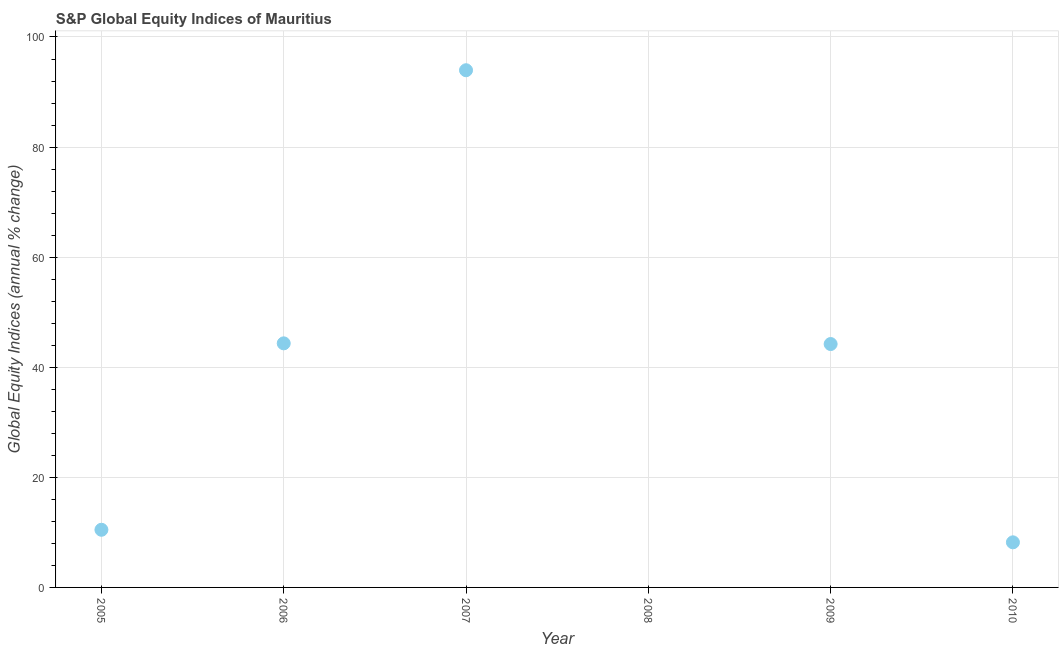What is the s&p global equity indices in 2007?
Offer a terse response. 93.96. Across all years, what is the maximum s&p global equity indices?
Your response must be concise. 93.96. In which year was the s&p global equity indices maximum?
Offer a terse response. 2007. What is the sum of the s&p global equity indices?
Your response must be concise. 201.19. What is the difference between the s&p global equity indices in 2005 and 2009?
Offer a very short reply. -33.74. What is the average s&p global equity indices per year?
Your answer should be compact. 33.53. What is the median s&p global equity indices?
Ensure brevity in your answer.  27.35. In how many years, is the s&p global equity indices greater than 16 %?
Your answer should be very brief. 3. What is the ratio of the s&p global equity indices in 2005 to that in 2009?
Offer a very short reply. 0.24. Is the s&p global equity indices in 2006 less than that in 2009?
Offer a terse response. No. What is the difference between the highest and the second highest s&p global equity indices?
Provide a succinct answer. 49.62. Is the sum of the s&p global equity indices in 2005 and 2006 greater than the maximum s&p global equity indices across all years?
Ensure brevity in your answer.  No. What is the difference between the highest and the lowest s&p global equity indices?
Keep it short and to the point. 93.96. Does the s&p global equity indices monotonically increase over the years?
Offer a very short reply. No. How many years are there in the graph?
Provide a succinct answer. 6. Does the graph contain grids?
Ensure brevity in your answer.  Yes. What is the title of the graph?
Your answer should be compact. S&P Global Equity Indices of Mauritius. What is the label or title of the X-axis?
Your answer should be compact. Year. What is the label or title of the Y-axis?
Your response must be concise. Global Equity Indices (annual % change). What is the Global Equity Indices (annual % change) in 2005?
Keep it short and to the point. 10.47. What is the Global Equity Indices (annual % change) in 2006?
Provide a succinct answer. 44.34. What is the Global Equity Indices (annual % change) in 2007?
Your answer should be very brief. 93.96. What is the Global Equity Indices (annual % change) in 2009?
Your response must be concise. 44.22. What is the Global Equity Indices (annual % change) in 2010?
Give a very brief answer. 8.19. What is the difference between the Global Equity Indices (annual % change) in 2005 and 2006?
Provide a succinct answer. -33.87. What is the difference between the Global Equity Indices (annual % change) in 2005 and 2007?
Your response must be concise. -83.48. What is the difference between the Global Equity Indices (annual % change) in 2005 and 2009?
Offer a terse response. -33.74. What is the difference between the Global Equity Indices (annual % change) in 2005 and 2010?
Make the answer very short. 2.28. What is the difference between the Global Equity Indices (annual % change) in 2006 and 2007?
Keep it short and to the point. -49.62. What is the difference between the Global Equity Indices (annual % change) in 2006 and 2009?
Your answer should be compact. 0.13. What is the difference between the Global Equity Indices (annual % change) in 2006 and 2010?
Make the answer very short. 36.15. What is the difference between the Global Equity Indices (annual % change) in 2007 and 2009?
Ensure brevity in your answer.  49.74. What is the difference between the Global Equity Indices (annual % change) in 2007 and 2010?
Your answer should be very brief. 85.77. What is the difference between the Global Equity Indices (annual % change) in 2009 and 2010?
Offer a very short reply. 36.02. What is the ratio of the Global Equity Indices (annual % change) in 2005 to that in 2006?
Provide a succinct answer. 0.24. What is the ratio of the Global Equity Indices (annual % change) in 2005 to that in 2007?
Your answer should be compact. 0.11. What is the ratio of the Global Equity Indices (annual % change) in 2005 to that in 2009?
Provide a short and direct response. 0.24. What is the ratio of the Global Equity Indices (annual % change) in 2005 to that in 2010?
Provide a succinct answer. 1.28. What is the ratio of the Global Equity Indices (annual % change) in 2006 to that in 2007?
Give a very brief answer. 0.47. What is the ratio of the Global Equity Indices (annual % change) in 2006 to that in 2010?
Make the answer very short. 5.41. What is the ratio of the Global Equity Indices (annual % change) in 2007 to that in 2009?
Keep it short and to the point. 2.12. What is the ratio of the Global Equity Indices (annual % change) in 2007 to that in 2010?
Offer a very short reply. 11.47. What is the ratio of the Global Equity Indices (annual % change) in 2009 to that in 2010?
Ensure brevity in your answer.  5.4. 